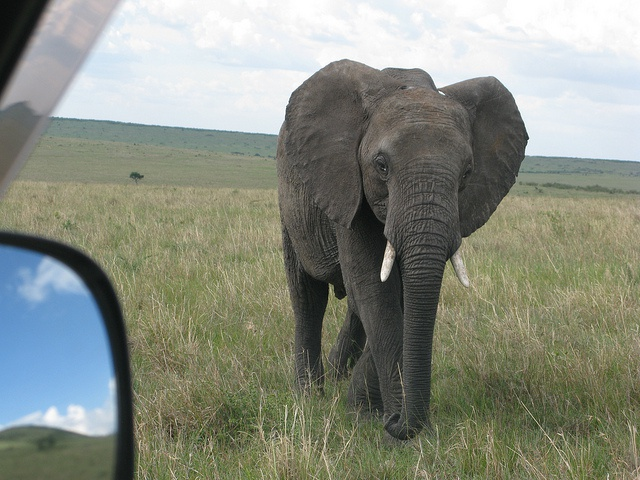Describe the objects in this image and their specific colors. I can see elephant in black and gray tones and car in black, lightblue, gray, and darkgray tones in this image. 